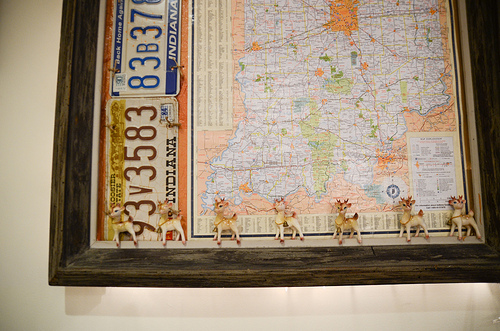<image>
Is there a deer in front of the map? Yes. The deer is positioned in front of the map, appearing closer to the camera viewpoint. 